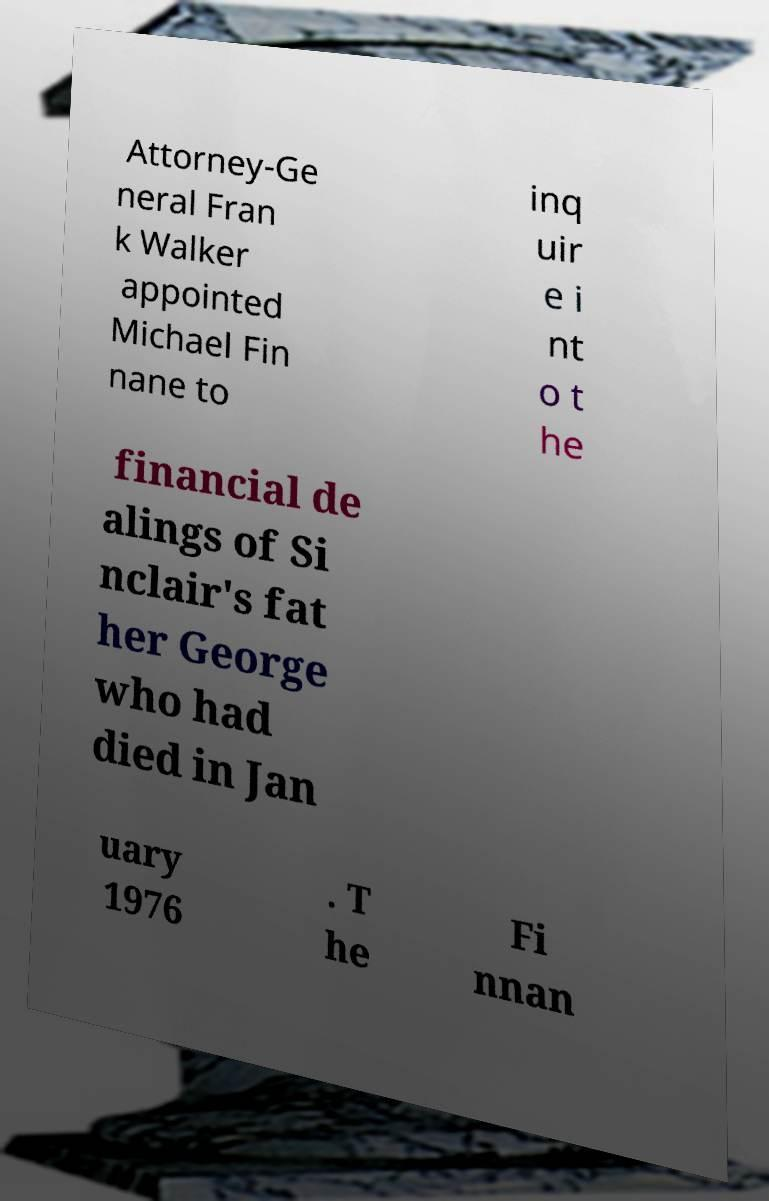Please identify and transcribe the text found in this image. Attorney-Ge neral Fran k Walker appointed Michael Fin nane to inq uir e i nt o t he financial de alings of Si nclair's fat her George who had died in Jan uary 1976 . T he Fi nnan 